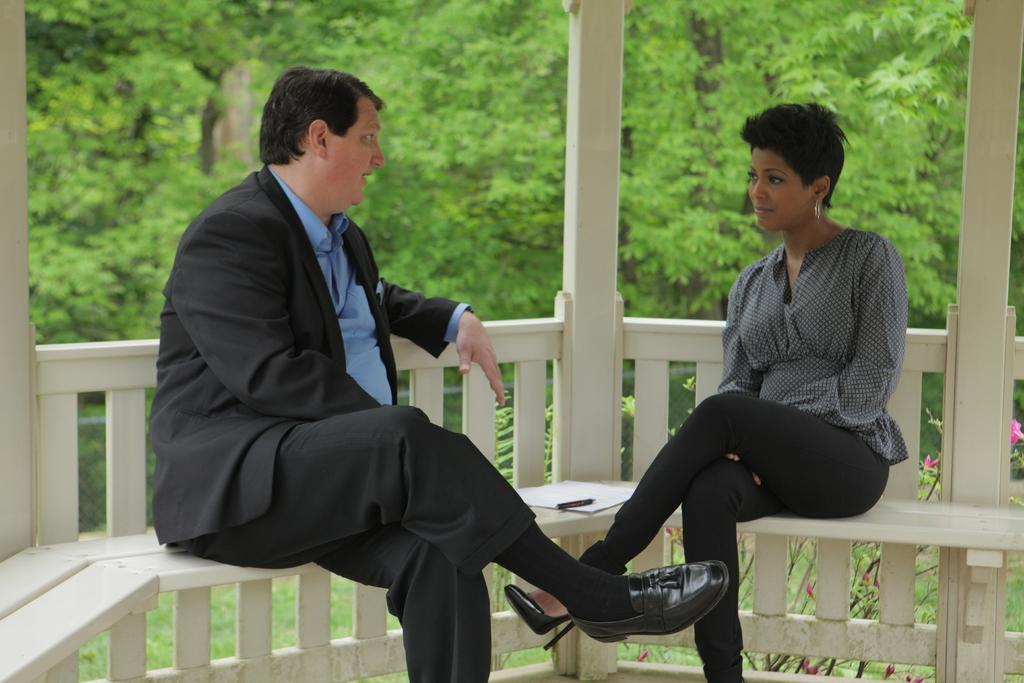Describe this image in one or two sentences. This image is taken outdoors. In the background there are many trees and plants with green leaves. In the middle of the image a man and a woman are sitting on the bench and there is a paper on the bench. There is a wooden railing. 